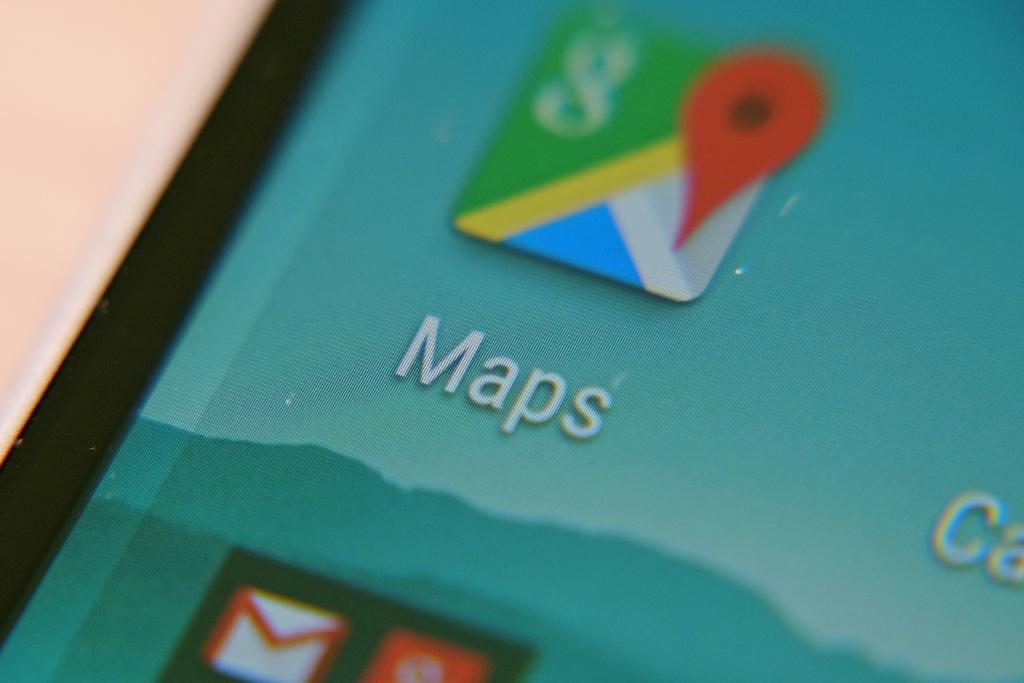<image>
Give a short and clear explanation of the subsequent image. A cellphone with a blue background screen that says Maps and an icon 